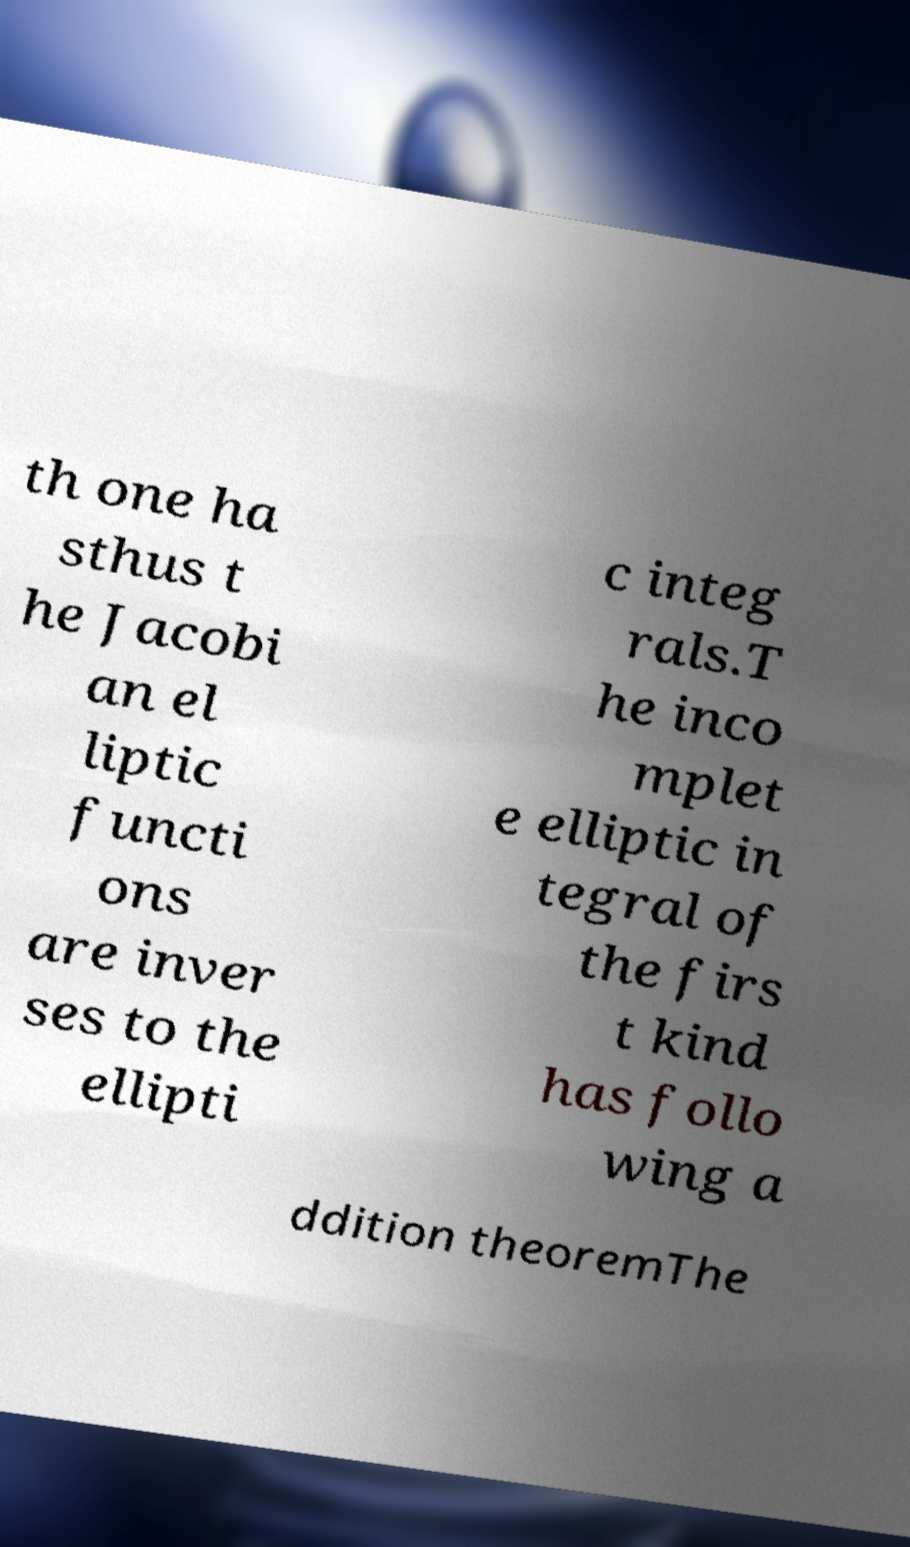Could you assist in decoding the text presented in this image and type it out clearly? th one ha sthus t he Jacobi an el liptic functi ons are inver ses to the ellipti c integ rals.T he inco mplet e elliptic in tegral of the firs t kind has follo wing a ddition theoremThe 